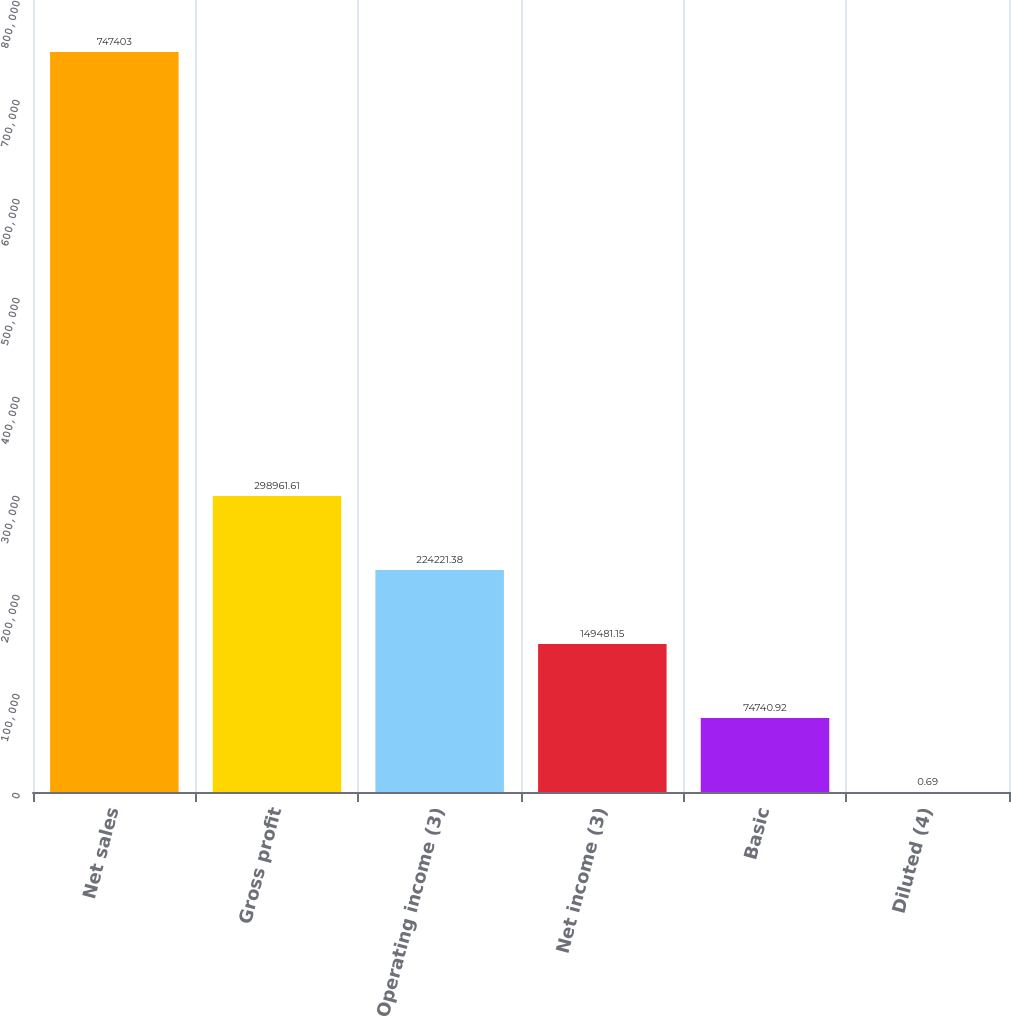<chart> <loc_0><loc_0><loc_500><loc_500><bar_chart><fcel>Net sales<fcel>Gross profit<fcel>Operating income (3)<fcel>Net income (3)<fcel>Basic<fcel>Diluted (4)<nl><fcel>747403<fcel>298962<fcel>224221<fcel>149481<fcel>74740.9<fcel>0.69<nl></chart> 